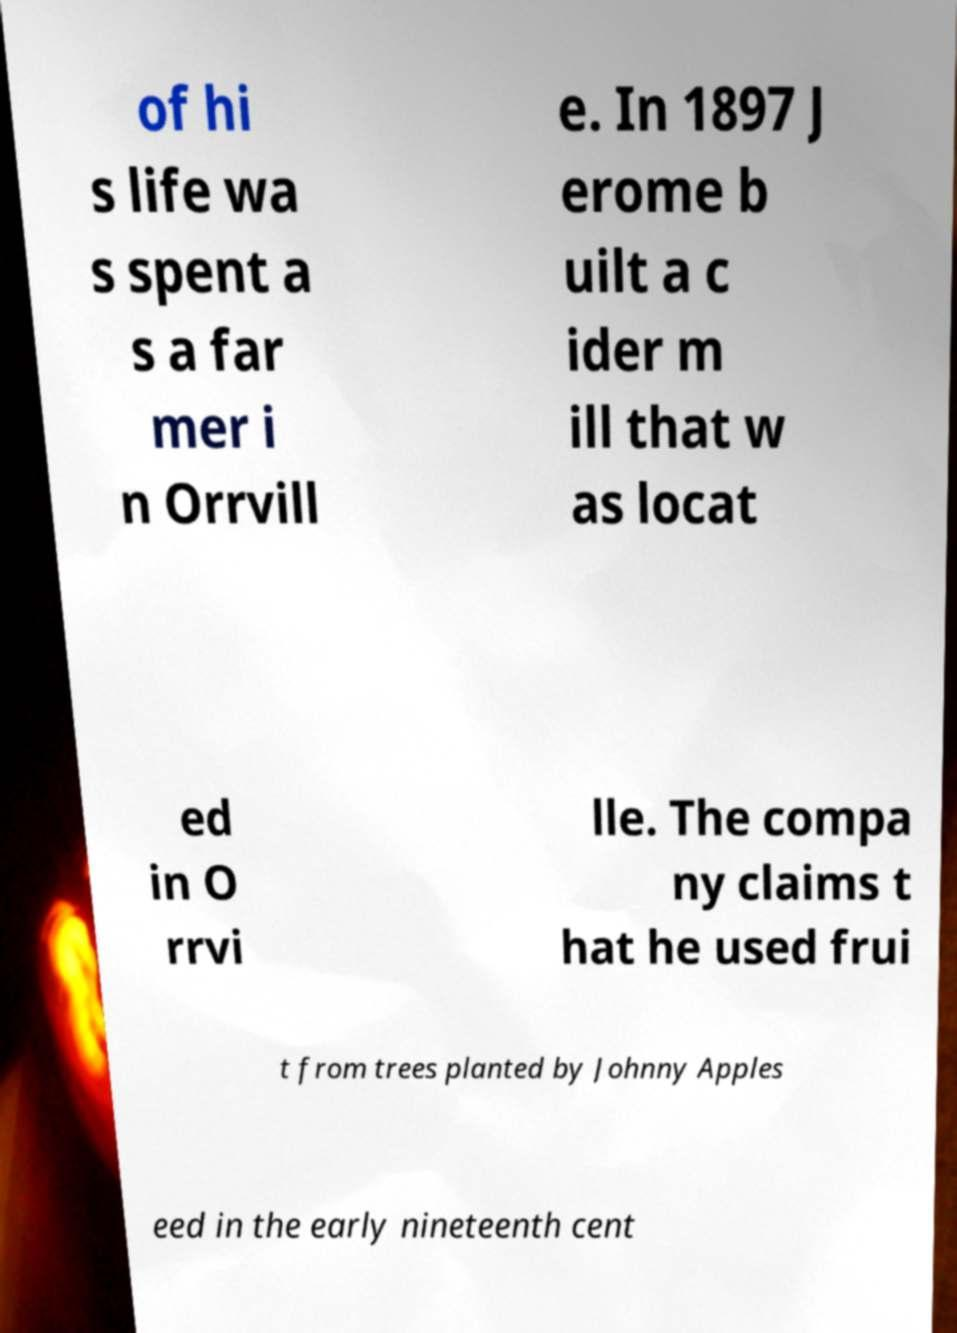Please read and relay the text visible in this image. What does it say? of hi s life wa s spent a s a far mer i n Orrvill e. In 1897 J erome b uilt a c ider m ill that w as locat ed in O rrvi lle. The compa ny claims t hat he used frui t from trees planted by Johnny Apples eed in the early nineteenth cent 